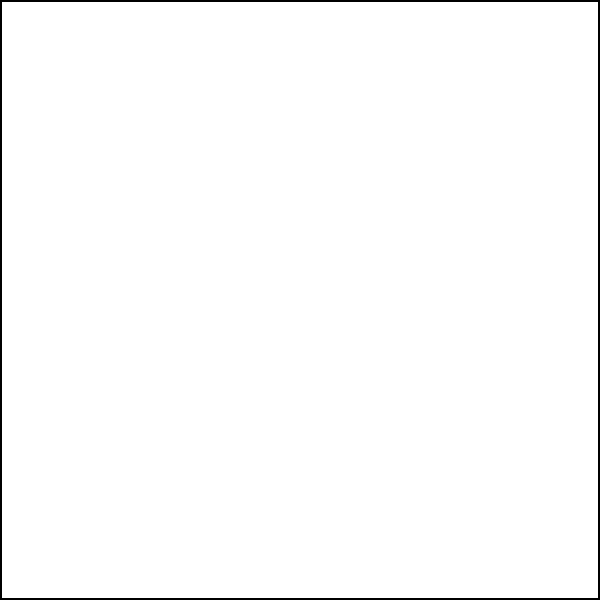As a sustainable construction expert, you're designing a bike-friendly intersection. Given that the minimum comfortable leaning angle for cyclists is 20°, what is the minimum turning radius (R) required for a 90° turn in a bike lane that is 1.5 meters wide? To determine the minimum turning radius for a bike lane at an intersection, we need to consider the comfortable leaning angle for cyclists and the width of the bike lane. Let's approach this step-by-step:

1) The comfortable leaning angle (θ) is given as 20°.

2) The width of the bike lane is 1.5 meters.

3) In a right-angled turn, the relationship between the radius (R), the width of the lane (w), and the leaning angle (θ) is given by the formula:

   $R = \frac{w}{\tan θ}$

4) Substituting the values:
   $R = \frac{1.5}{\tan 20°}$

5) Calculate $\tan 20°$:
   $\tan 20° ≈ 0.3640$

6) Now, we can solve for R:
   $R = \frac{1.5}{0.3640} ≈ 4.12$ meters

7) Rounding up to ensure safety, we get a minimum turning radius of 4.2 meters.

This radius will allow cyclists to comfortably navigate the 90° turn while maintaining a safe leaning angle.
Answer: 4.2 meters 